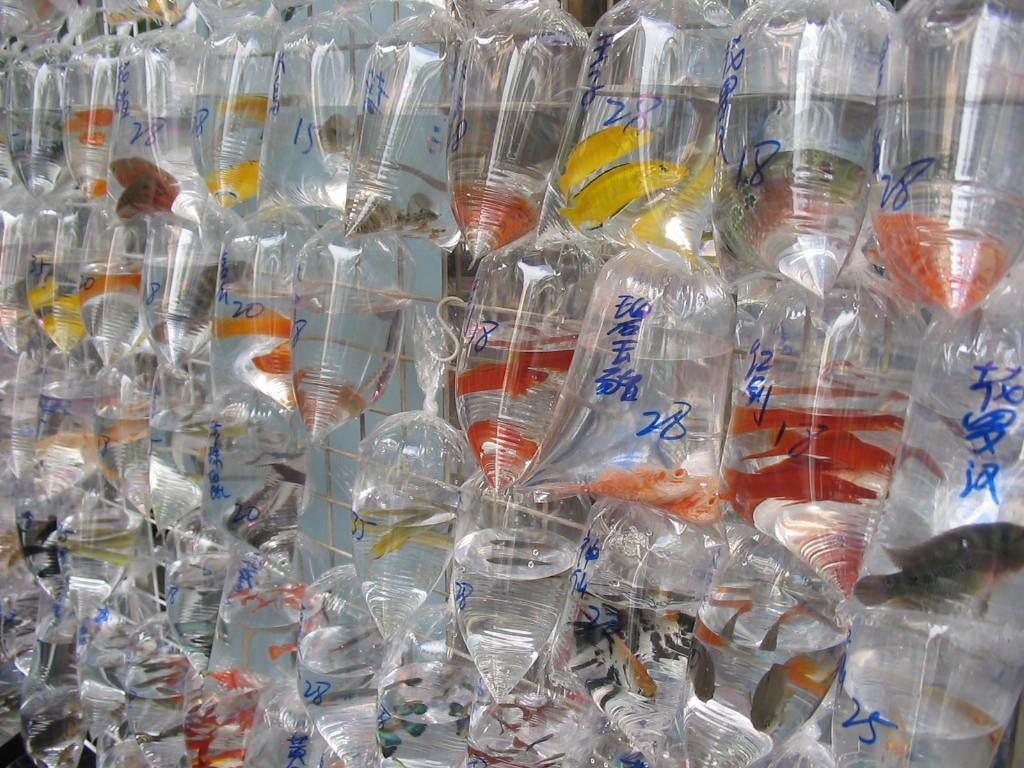What is the main object in the image? There is a grille in the image. What can be seen inside the grille? There are fishes visible in the image. How are the fishes packaged? The fishes are packed in transparent covers. Are there any additional details on the packaging? Yes, there is writing on the transparent covers. What might be used to hang the fishes? There are hooks in the image that could be used to hang the fishes. What type of birth can be seen taking place in the image? There is no birth taking place in the image; it features a grille with fishes packed in transparent covers. What kind of operation is being performed on the fishes in the image? There is no operation being performed on the fishes in the image; they are simply packaged in transparent covers. 